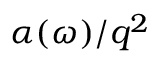Convert formula to latex. <formula><loc_0><loc_0><loc_500><loc_500>\alpha ( \omega ) / q ^ { 2 }</formula> 